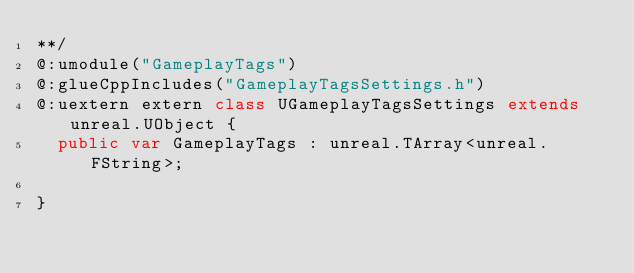Convert code to text. <code><loc_0><loc_0><loc_500><loc_500><_Haxe_>**/
@:umodule("GameplayTags")
@:glueCppIncludes("GameplayTagsSettings.h")
@:uextern extern class UGameplayTagsSettings extends unreal.UObject {
  public var GameplayTags : unreal.TArray<unreal.FString>;
  
}
</code> 